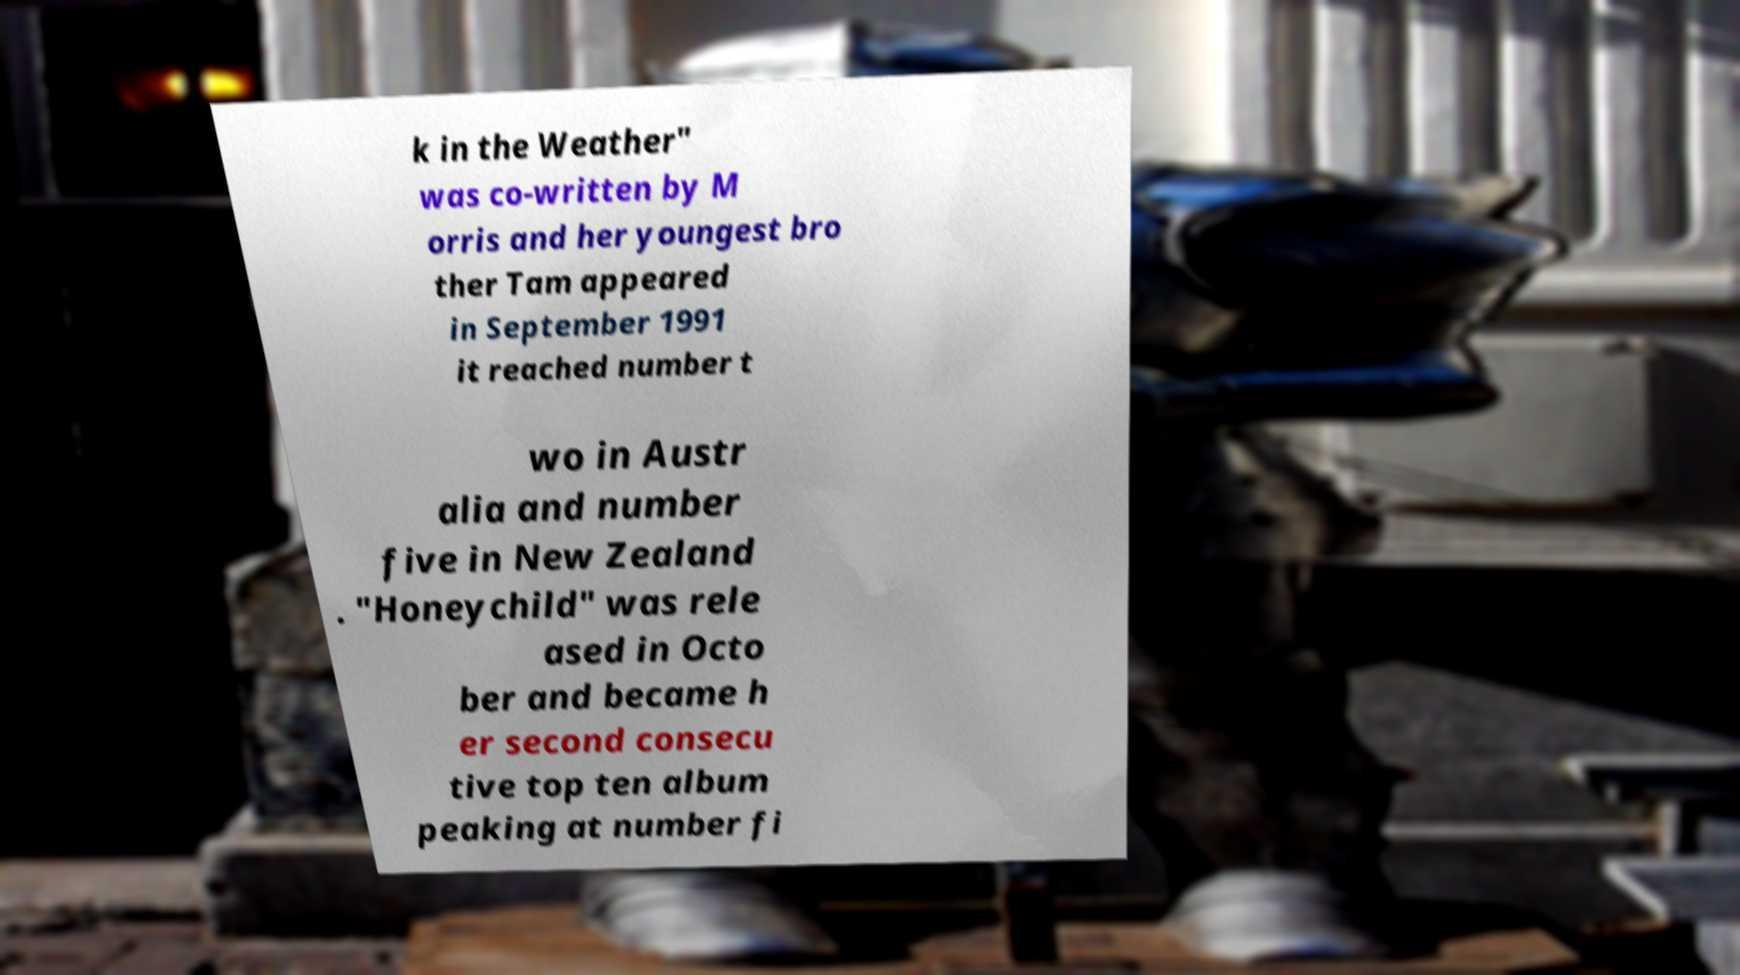Can you read and provide the text displayed in the image?This photo seems to have some interesting text. Can you extract and type it out for me? k in the Weather" was co-written by M orris and her youngest bro ther Tam appeared in September 1991 it reached number t wo in Austr alia and number five in New Zealand . "Honeychild" was rele ased in Octo ber and became h er second consecu tive top ten album peaking at number fi 